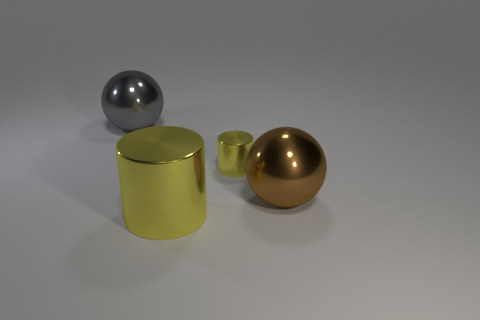There is a large sphere in front of the big gray object; what is its color?
Offer a terse response. Brown. Are there any large balls that are behind the large ball that is right of the small yellow shiny thing?
Ensure brevity in your answer.  Yes. Do the cylinder that is left of the tiny thing and the yellow cylinder to the right of the big yellow cylinder have the same size?
Your response must be concise. No. There is a yellow cylinder behind the ball that is in front of the gray object; what size is it?
Keep it short and to the point. Small. What color is the big metal cylinder?
Your answer should be very brief. Yellow. What shape is the yellow thing left of the tiny yellow cylinder?
Give a very brief answer. Cylinder. There is a sphere that is in front of the large gray sphere on the left side of the big cylinder; are there any big gray metallic objects to the right of it?
Offer a very short reply. No. Are there any big green cylinders?
Provide a succinct answer. No. What size is the yellow shiny cylinder that is behind the big metal sphere that is in front of the yellow metallic object right of the big yellow cylinder?
Offer a very short reply. Small. How many other yellow cylinders have the same material as the tiny cylinder?
Your response must be concise. 1. 